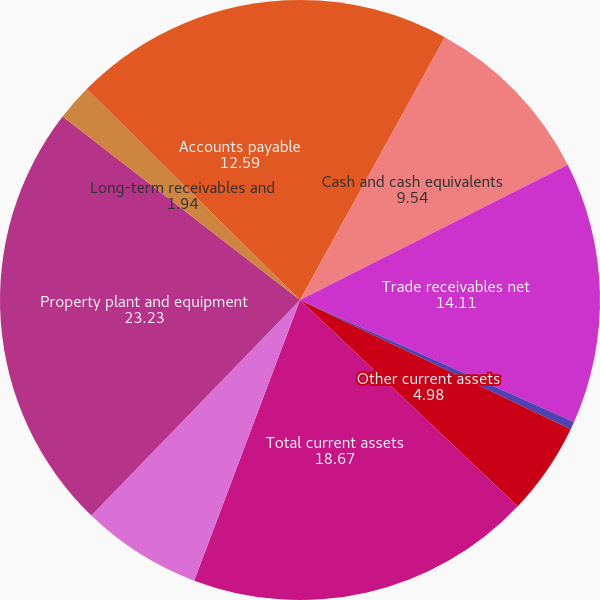<chart> <loc_0><loc_0><loc_500><loc_500><pie_chart><fcel>(in millions)<fcel>Cash and cash equivalents<fcel>Trade receivables net<fcel>Inventories<fcel>Other current assets<fcel>Total current assets<fcel>Investments in unconsolidated<fcel>Property plant and equipment<fcel>Long-term receivables and<fcel>Accounts payable<nl><fcel>8.02%<fcel>9.54%<fcel>14.11%<fcel>0.42%<fcel>4.98%<fcel>18.67%<fcel>6.5%<fcel>23.23%<fcel>1.94%<fcel>12.59%<nl></chart> 